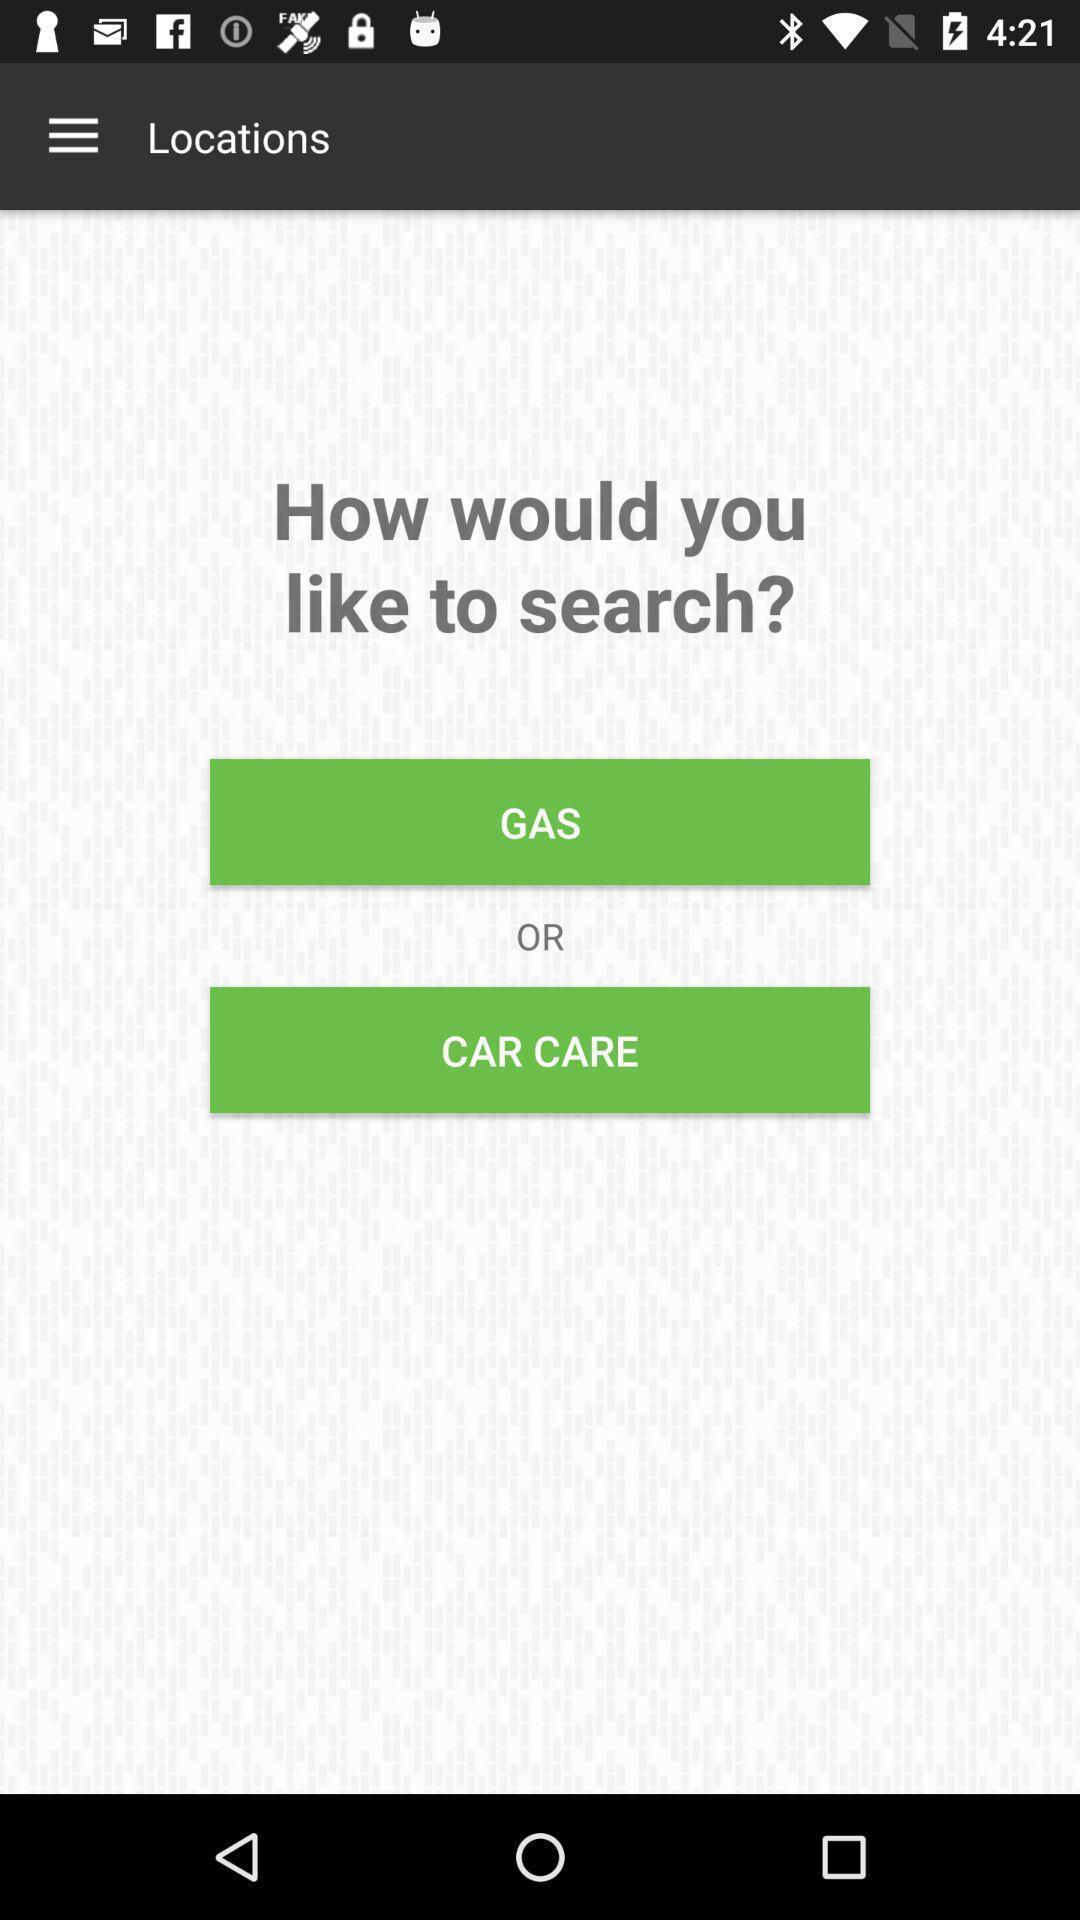Provide a description of this screenshot. Search options page of a car care app. 